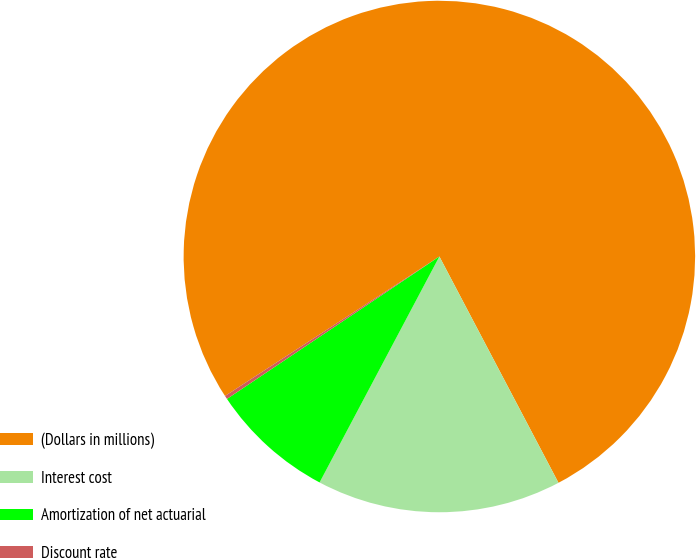Convert chart. <chart><loc_0><loc_0><loc_500><loc_500><pie_chart><fcel>(Dollars in millions)<fcel>Interest cost<fcel>Amortization of net actuarial<fcel>Discount rate<nl><fcel>76.47%<fcel>15.47%<fcel>7.84%<fcel>0.22%<nl></chart> 